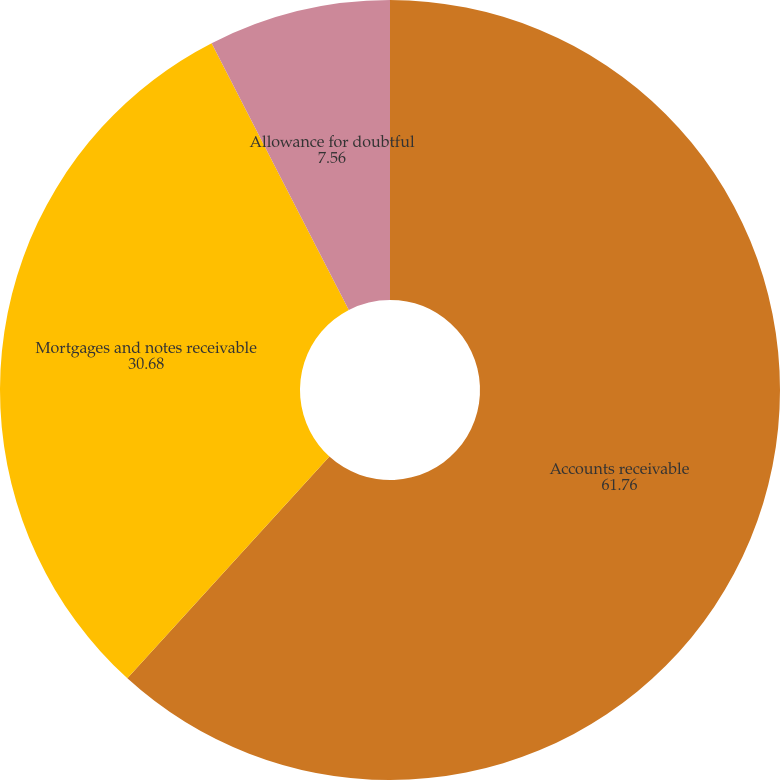Convert chart. <chart><loc_0><loc_0><loc_500><loc_500><pie_chart><fcel>Accounts receivable<fcel>Mortgages and notes receivable<fcel>Allowance for doubtful<nl><fcel>61.76%<fcel>30.68%<fcel>7.56%<nl></chart> 